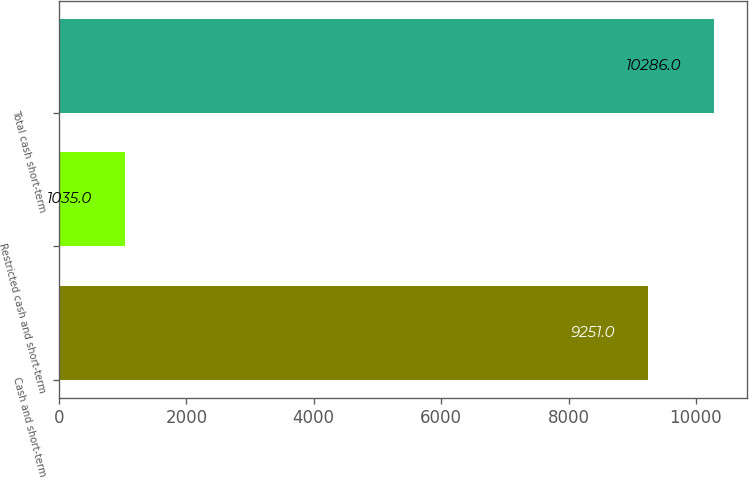Convert chart. <chart><loc_0><loc_0><loc_500><loc_500><bar_chart><fcel>Cash and short-term<fcel>Restricted cash and short-term<fcel>Total cash short-term<nl><fcel>9251<fcel>1035<fcel>10286<nl></chart> 